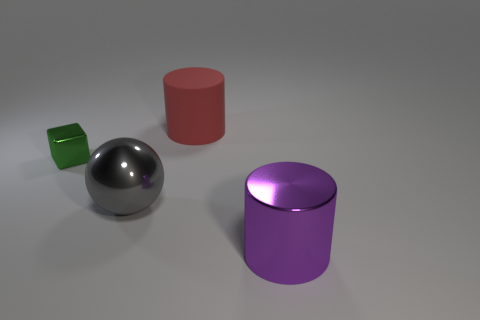There is a metal thing that is on the right side of the gray metal sphere; what is its shape? The object to the right of the gray metal sphere is a cylinder, with a shiny purple surface that reflects some of the environment. It has a smooth curved sides and a flat top, typical characteristics of cylindrical shapes. 